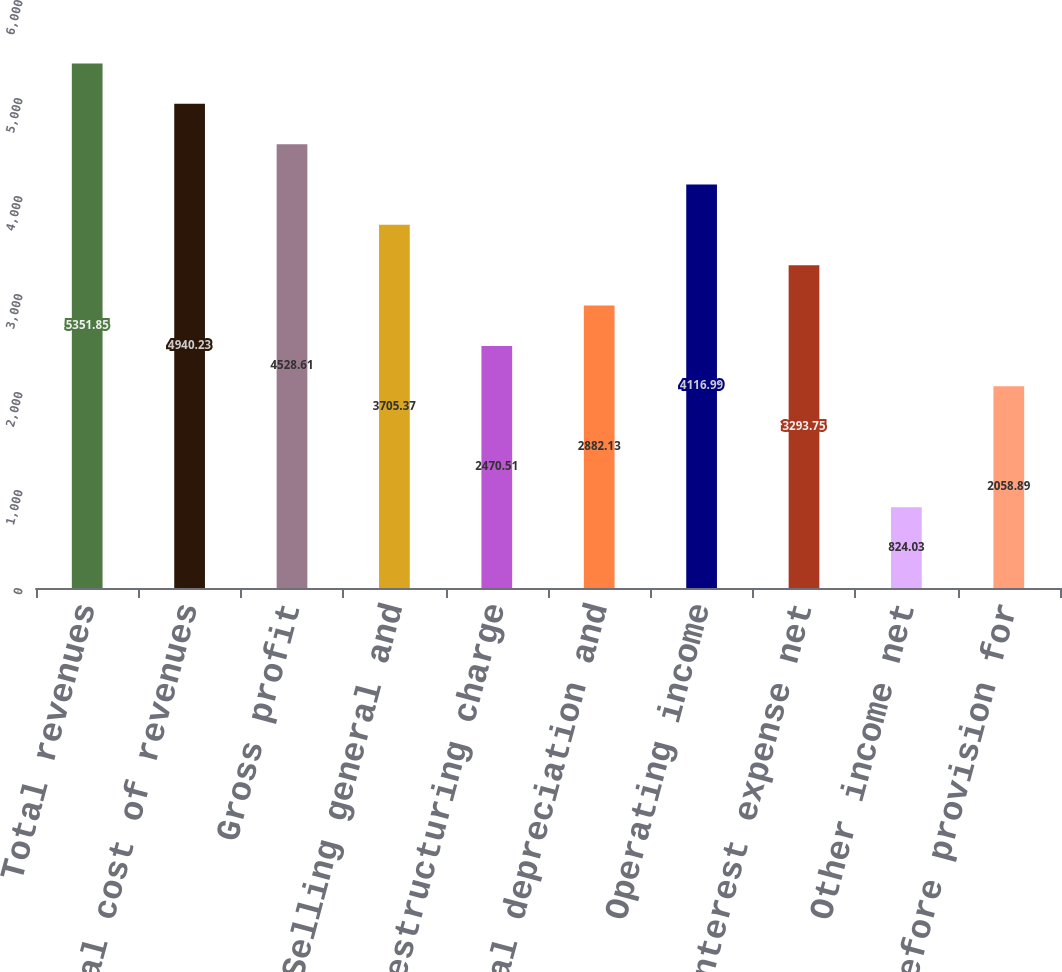<chart> <loc_0><loc_0><loc_500><loc_500><bar_chart><fcel>Total revenues<fcel>Total cost of revenues<fcel>Gross profit<fcel>Selling general and<fcel>Restructuring charge<fcel>Non-rental depreciation and<fcel>Operating income<fcel>Interest expense net<fcel>Other income net<fcel>Income before provision for<nl><fcel>5351.85<fcel>4940.23<fcel>4528.61<fcel>3705.37<fcel>2470.51<fcel>2882.13<fcel>4116.99<fcel>3293.75<fcel>824.03<fcel>2058.89<nl></chart> 